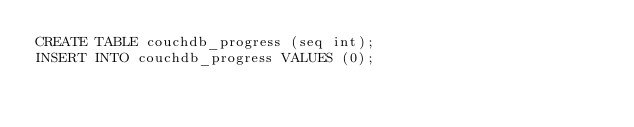Convert code to text. <code><loc_0><loc_0><loc_500><loc_500><_SQL_>CREATE TABLE couchdb_progress (seq int);
INSERT INTO couchdb_progress VALUES (0);
</code> 